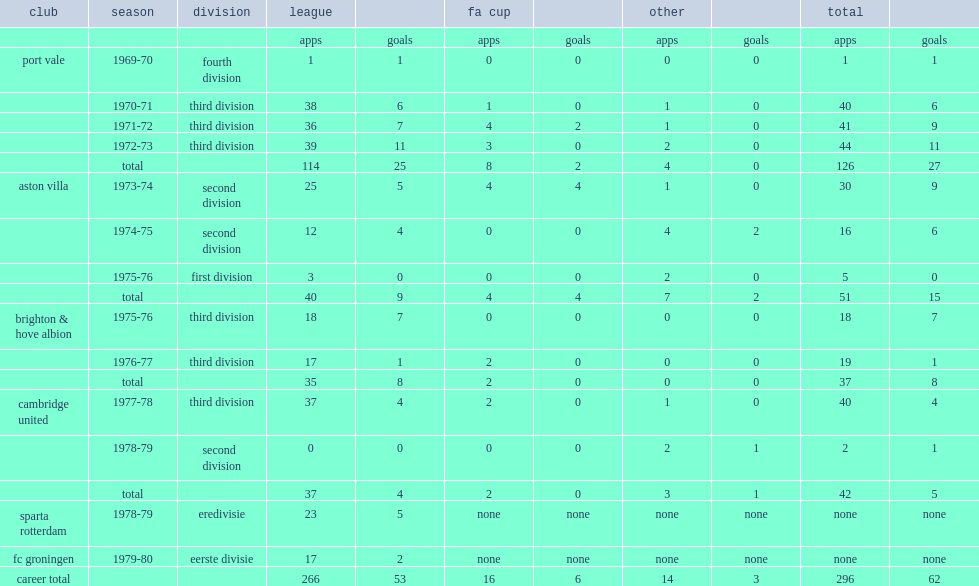Which division did sammy morgan play for fc groningen in 1979-80? Eerste divisie. 